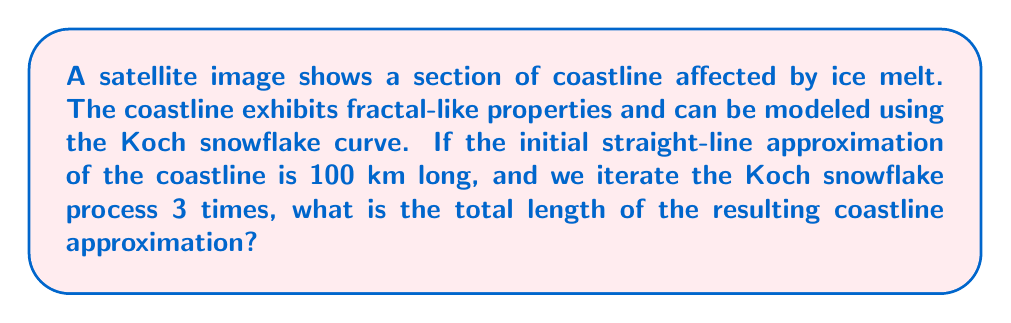Can you answer this question? To solve this problem, we'll follow these steps:

1) Recall the Koch snowflake construction:
   - Each line segment is divided into three equal parts
   - The middle part is replaced by two sides of an equilateral triangle

2) Calculate the scaling factor for each iteration:
   - Each segment is replaced by 4 segments, each 1/3 the original length
   - So the length multiplies by $4/3$ in each iteration

3) Apply the scaling factor for 3 iterations:
   $$L = L_0 \cdot (4/3)^3$$
   where $L_0$ is the initial length and $L$ is the final length

4) Substitute the given values:
   $$L = 100 \cdot (4/3)^3$$

5) Calculate:
   $$L = 100 \cdot (64/27)$$
   $$L = 100 \cdot 2.37037...$$
   $$L \approx 237.04$$

Therefore, after 3 iterations, the approximated coastline length is about 237.04 km.
Answer: $237.04$ km 